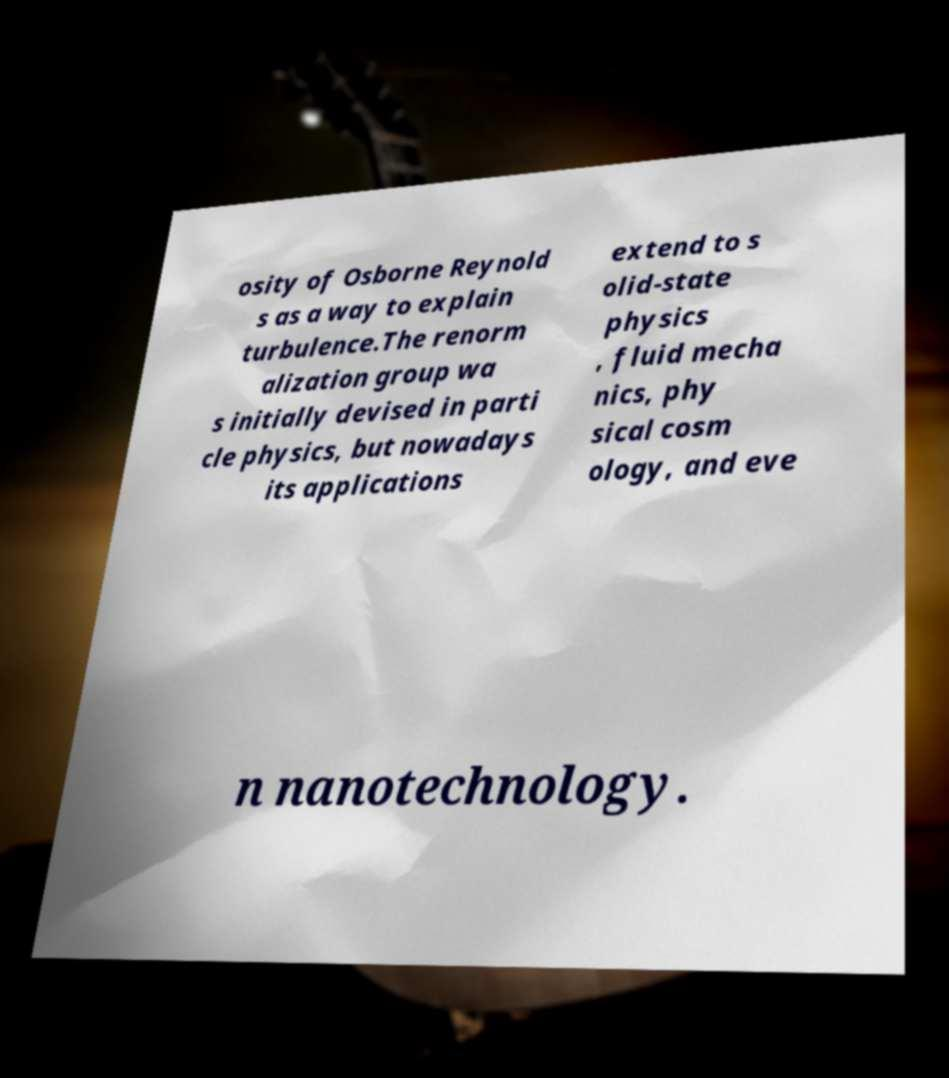There's text embedded in this image that I need extracted. Can you transcribe it verbatim? osity of Osborne Reynold s as a way to explain turbulence.The renorm alization group wa s initially devised in parti cle physics, but nowadays its applications extend to s olid-state physics , fluid mecha nics, phy sical cosm ology, and eve n nanotechnology. 